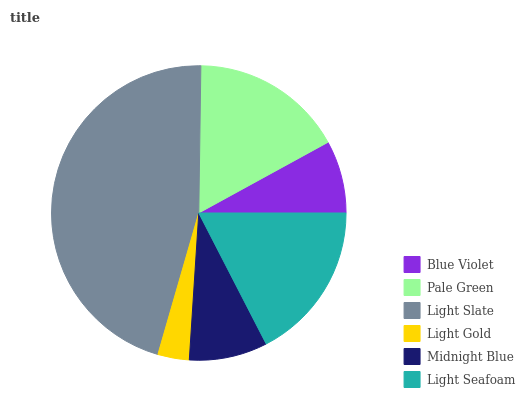Is Light Gold the minimum?
Answer yes or no. Yes. Is Light Slate the maximum?
Answer yes or no. Yes. Is Pale Green the minimum?
Answer yes or no. No. Is Pale Green the maximum?
Answer yes or no. No. Is Pale Green greater than Blue Violet?
Answer yes or no. Yes. Is Blue Violet less than Pale Green?
Answer yes or no. Yes. Is Blue Violet greater than Pale Green?
Answer yes or no. No. Is Pale Green less than Blue Violet?
Answer yes or no. No. Is Pale Green the high median?
Answer yes or no. Yes. Is Midnight Blue the low median?
Answer yes or no. Yes. Is Blue Violet the high median?
Answer yes or no. No. Is Light Seafoam the low median?
Answer yes or no. No. 